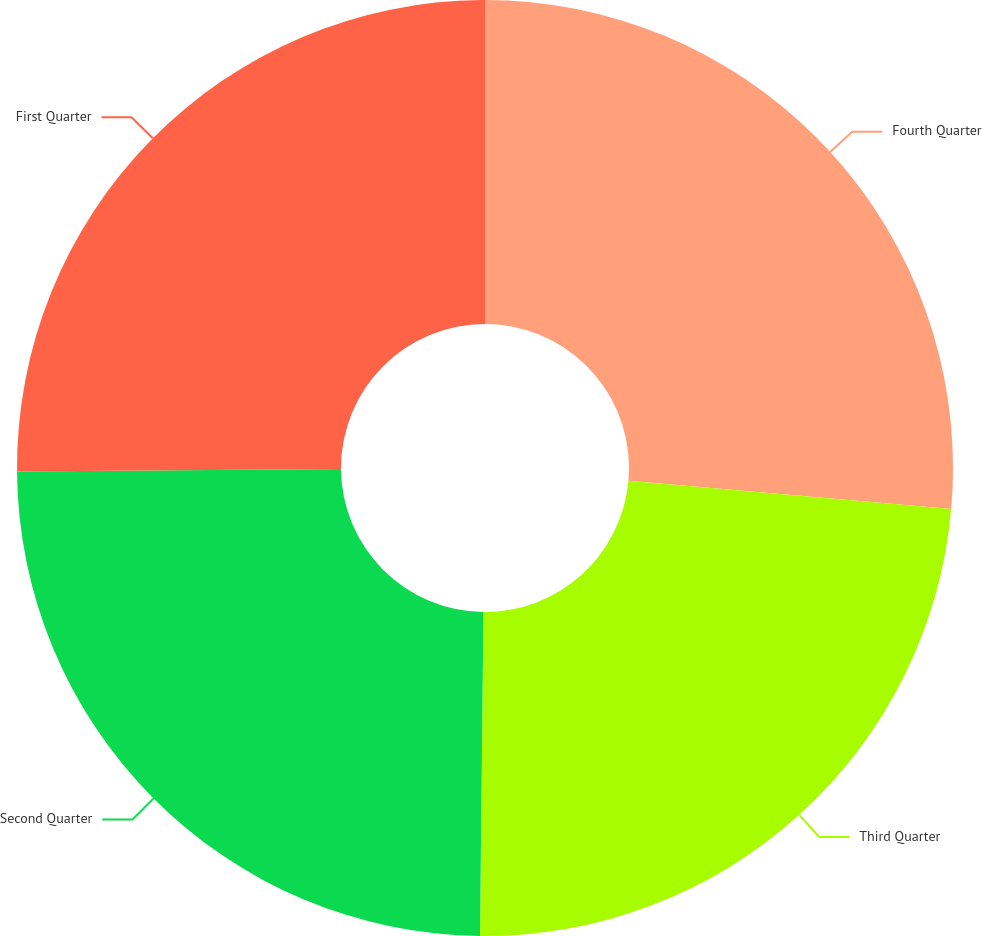Convert chart. <chart><loc_0><loc_0><loc_500><loc_500><pie_chart><fcel>Fourth Quarter<fcel>Third Quarter<fcel>Second Quarter<fcel>First Quarter<nl><fcel>26.4%<fcel>23.77%<fcel>24.71%<fcel>25.12%<nl></chart> 